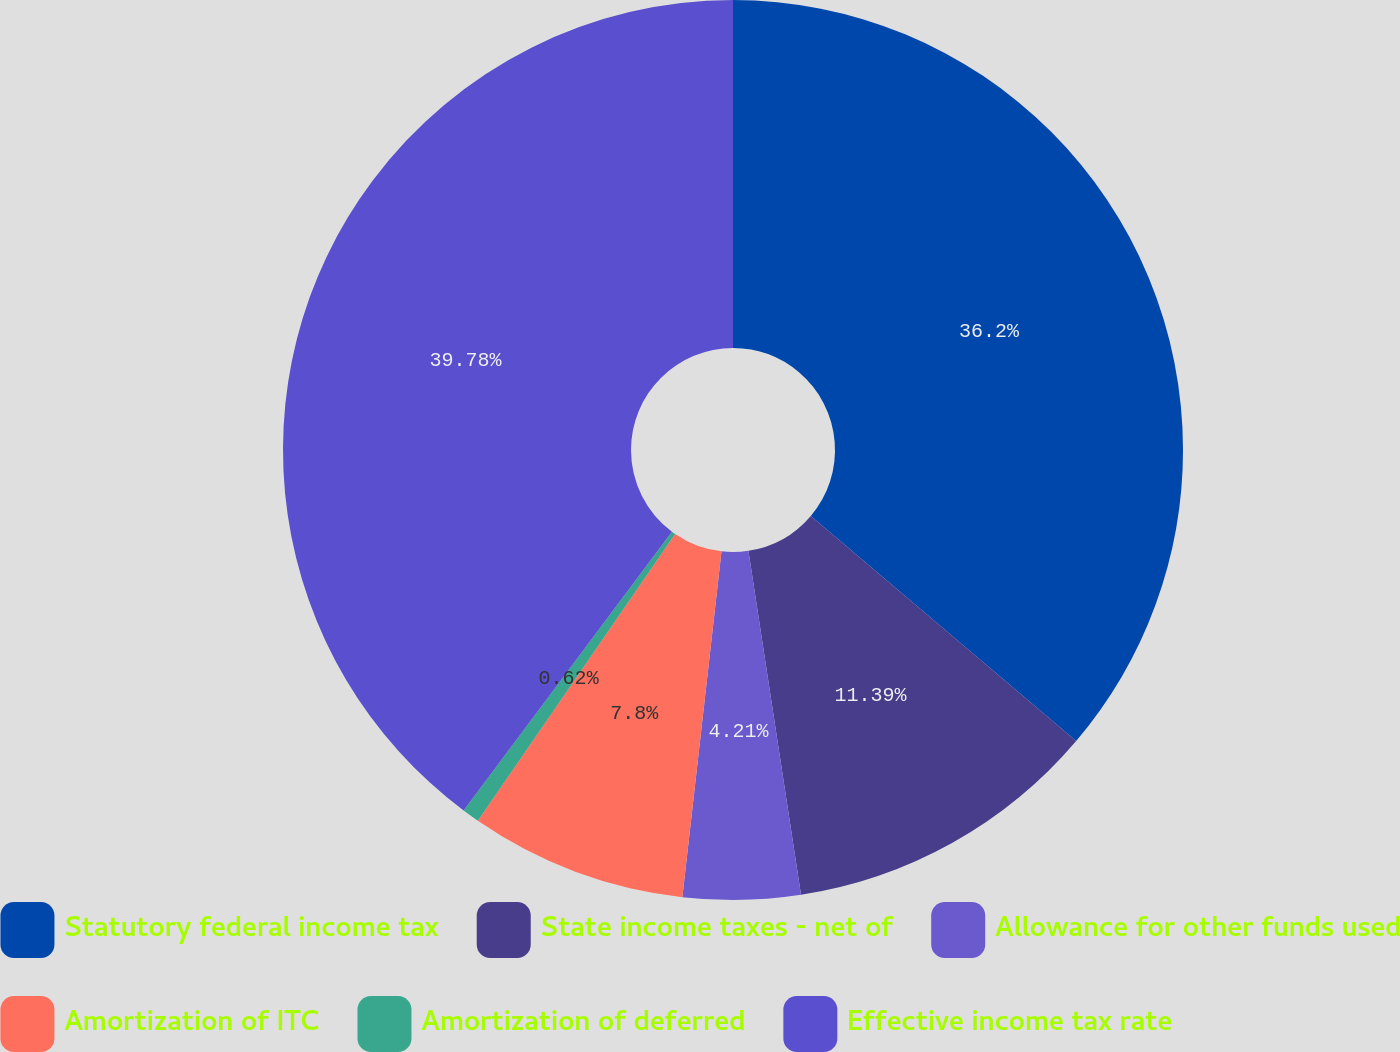<chart> <loc_0><loc_0><loc_500><loc_500><pie_chart><fcel>Statutory federal income tax<fcel>State income taxes - net of<fcel>Allowance for other funds used<fcel>Amortization of ITC<fcel>Amortization of deferred<fcel>Effective income tax rate<nl><fcel>36.2%<fcel>11.39%<fcel>4.21%<fcel>7.8%<fcel>0.62%<fcel>39.79%<nl></chart> 